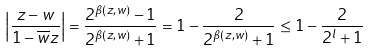<formula> <loc_0><loc_0><loc_500><loc_500>\left | \frac { z - w } { 1 - \overline { w } z } \right | = \frac { 2 ^ { \beta ( z , w ) } - 1 } { 2 ^ { \beta ( z , w ) } + 1 } = 1 - \frac { 2 } { 2 ^ { \beta ( z , w ) } + 1 } \leq 1 - \frac { 2 } { 2 ^ { l } + 1 }</formula> 